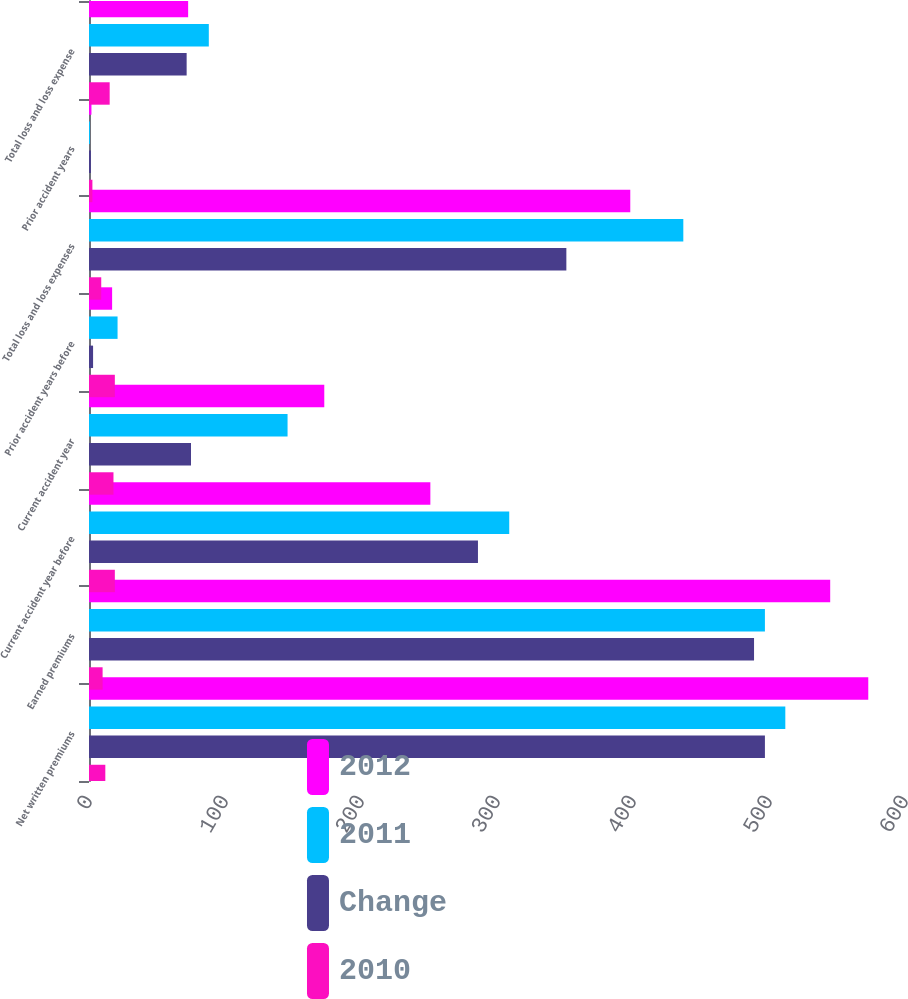<chart> <loc_0><loc_0><loc_500><loc_500><stacked_bar_chart><ecel><fcel>Net written premiums<fcel>Earned premiums<fcel>Current accident year before<fcel>Current accident year<fcel>Prior accident years before<fcel>Total loss and loss expenses<fcel>Prior accident years<fcel>Total loss and loss expense<nl><fcel>2012<fcel>573<fcel>545<fcel>251<fcel>173<fcel>17<fcel>398<fcel>1.8<fcel>72.9<nl><fcel>2011<fcel>512<fcel>497<fcel>309<fcel>146<fcel>21<fcel>437<fcel>0.7<fcel>88.1<nl><fcel>Change<fcel>497<fcel>489<fcel>286<fcel>75<fcel>3<fcel>351<fcel>1.4<fcel>71.8<nl><fcel>2010<fcel>12<fcel>10<fcel>19<fcel>18<fcel>19<fcel>9<fcel>2.5<fcel>15.2<nl></chart> 